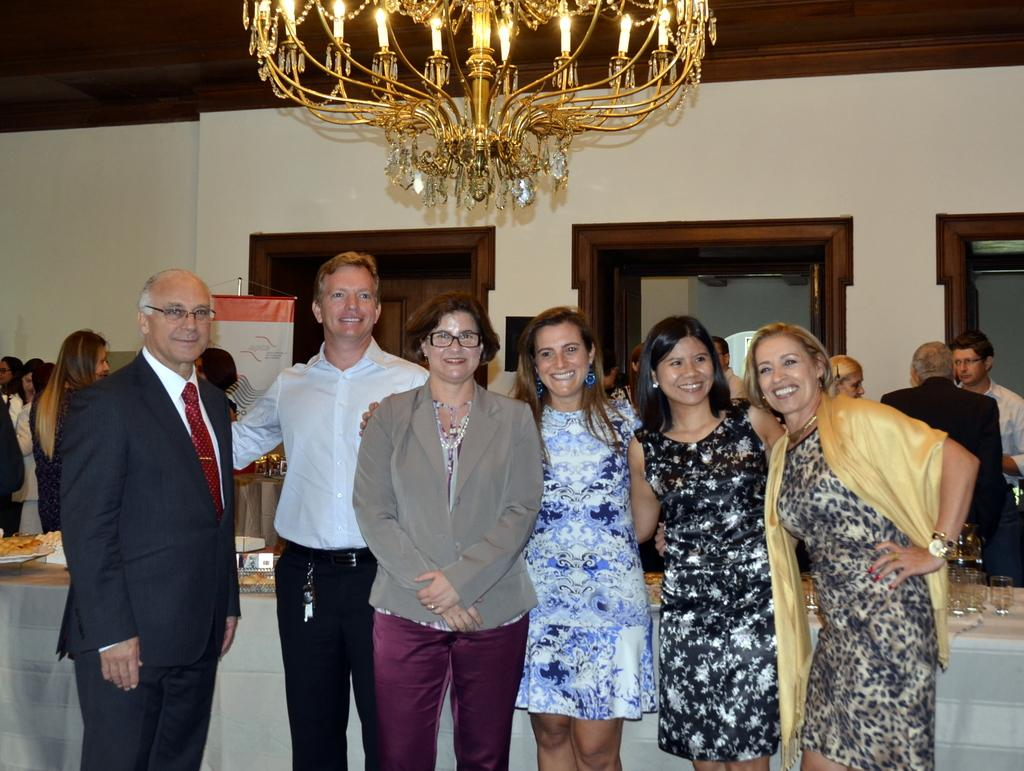What is the main subject of the image? The main subject of the image is a group of persons standing in the middle of the image. What can be seen in the background of the image? There is a wall in the background of the image. What is hanging from the ceiling in the image? There is a chandelier at the top of the image. How many pairs of trousers are visible on the persons in the image? There is no information about the type of clothing worn by the persons in the image, so it cannot be determined how many pairs of trousers are visible. 